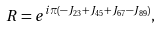<formula> <loc_0><loc_0><loc_500><loc_500>R = e ^ { i \pi ( - J _ { 2 3 } + J _ { 4 5 } + J _ { 6 7 } - J _ { 8 9 } ) } ,</formula> 